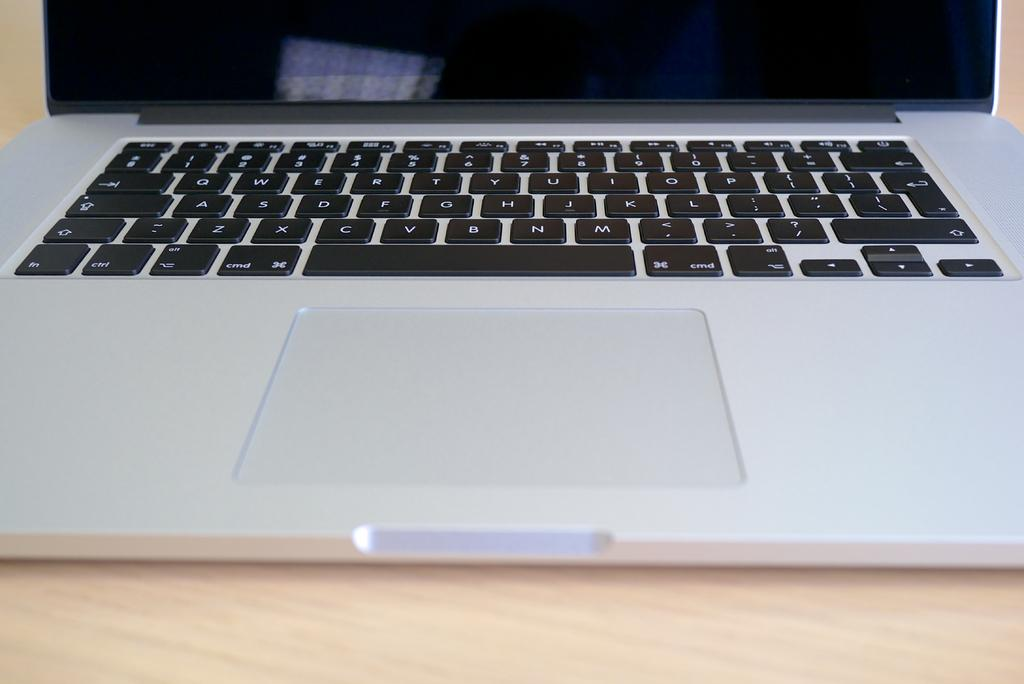<image>
Give a short and clear explanation of the subsequent image. An Apple laptop with black keys that say cmd on either side of the space bar. 